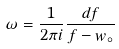Convert formula to latex. <formula><loc_0><loc_0><loc_500><loc_500>\omega = \frac { 1 } { 2 \pi i } \frac { d f } { f - w _ { \circ } }</formula> 